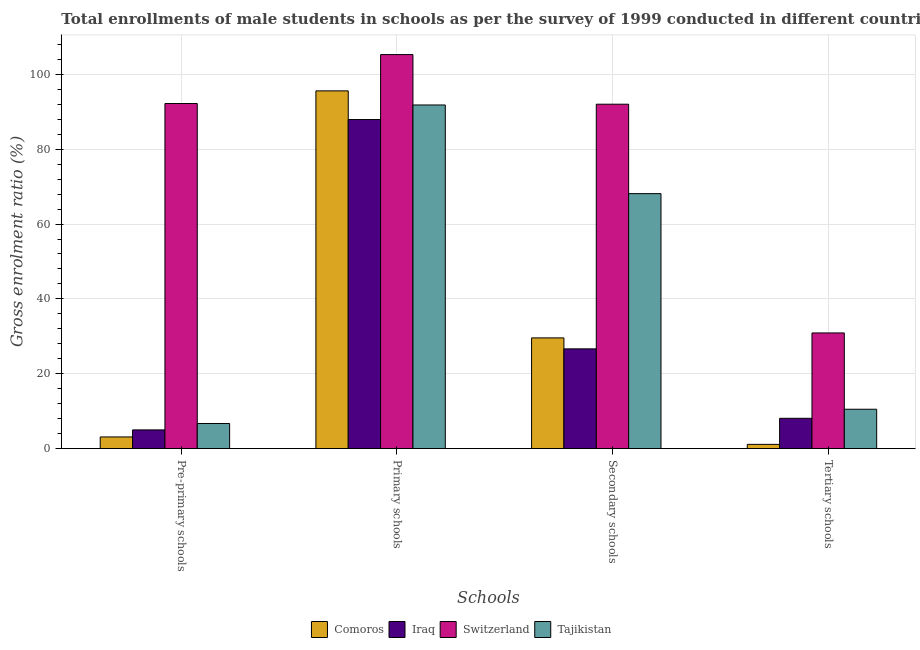How many groups of bars are there?
Your answer should be very brief. 4. Are the number of bars per tick equal to the number of legend labels?
Your response must be concise. Yes. Are the number of bars on each tick of the X-axis equal?
Make the answer very short. Yes. How many bars are there on the 3rd tick from the left?
Provide a short and direct response. 4. What is the label of the 3rd group of bars from the left?
Your answer should be compact. Secondary schools. What is the gross enrolment ratio(male) in tertiary schools in Switzerland?
Give a very brief answer. 30.91. Across all countries, what is the maximum gross enrolment ratio(male) in tertiary schools?
Provide a succinct answer. 30.91. Across all countries, what is the minimum gross enrolment ratio(male) in pre-primary schools?
Provide a succinct answer. 3.13. In which country was the gross enrolment ratio(male) in tertiary schools maximum?
Your answer should be very brief. Switzerland. In which country was the gross enrolment ratio(male) in primary schools minimum?
Offer a terse response. Iraq. What is the total gross enrolment ratio(male) in secondary schools in the graph?
Keep it short and to the point. 216.39. What is the difference between the gross enrolment ratio(male) in primary schools in Comoros and that in Switzerland?
Your response must be concise. -9.69. What is the difference between the gross enrolment ratio(male) in tertiary schools in Comoros and the gross enrolment ratio(male) in primary schools in Iraq?
Ensure brevity in your answer.  -86.76. What is the average gross enrolment ratio(male) in pre-primary schools per country?
Your answer should be compact. 26.77. What is the difference between the gross enrolment ratio(male) in secondary schools and gross enrolment ratio(male) in pre-primary schools in Switzerland?
Your response must be concise. -0.18. What is the ratio of the gross enrolment ratio(male) in primary schools in Iraq to that in Tajikistan?
Your answer should be very brief. 0.96. Is the gross enrolment ratio(male) in tertiary schools in Tajikistan less than that in Comoros?
Provide a short and direct response. No. Is the difference between the gross enrolment ratio(male) in pre-primary schools in Tajikistan and Switzerland greater than the difference between the gross enrolment ratio(male) in secondary schools in Tajikistan and Switzerland?
Make the answer very short. No. What is the difference between the highest and the second highest gross enrolment ratio(male) in tertiary schools?
Ensure brevity in your answer.  20.38. What is the difference between the highest and the lowest gross enrolment ratio(male) in pre-primary schools?
Provide a succinct answer. 89.06. Is it the case that in every country, the sum of the gross enrolment ratio(male) in pre-primary schools and gross enrolment ratio(male) in secondary schools is greater than the sum of gross enrolment ratio(male) in tertiary schools and gross enrolment ratio(male) in primary schools?
Provide a succinct answer. No. What does the 3rd bar from the left in Secondary schools represents?
Offer a very short reply. Switzerland. What does the 1st bar from the right in Secondary schools represents?
Keep it short and to the point. Tajikistan. Is it the case that in every country, the sum of the gross enrolment ratio(male) in pre-primary schools and gross enrolment ratio(male) in primary schools is greater than the gross enrolment ratio(male) in secondary schools?
Your response must be concise. Yes. Are all the bars in the graph horizontal?
Your response must be concise. No. How many legend labels are there?
Your answer should be compact. 4. What is the title of the graph?
Your answer should be compact. Total enrollments of male students in schools as per the survey of 1999 conducted in different countries. What is the label or title of the X-axis?
Your answer should be very brief. Schools. What is the label or title of the Y-axis?
Provide a succinct answer. Gross enrolment ratio (%). What is the Gross enrolment ratio (%) in Comoros in Pre-primary schools?
Offer a terse response. 3.13. What is the Gross enrolment ratio (%) of Iraq in Pre-primary schools?
Provide a short and direct response. 5.02. What is the Gross enrolment ratio (%) of Switzerland in Pre-primary schools?
Provide a short and direct response. 92.19. What is the Gross enrolment ratio (%) in Tajikistan in Pre-primary schools?
Your answer should be very brief. 6.73. What is the Gross enrolment ratio (%) in Comoros in Primary schools?
Your response must be concise. 95.57. What is the Gross enrolment ratio (%) of Iraq in Primary schools?
Give a very brief answer. 87.92. What is the Gross enrolment ratio (%) of Switzerland in Primary schools?
Ensure brevity in your answer.  105.27. What is the Gross enrolment ratio (%) of Tajikistan in Primary schools?
Keep it short and to the point. 91.8. What is the Gross enrolment ratio (%) of Comoros in Secondary schools?
Offer a very short reply. 29.59. What is the Gross enrolment ratio (%) of Iraq in Secondary schools?
Make the answer very short. 26.66. What is the Gross enrolment ratio (%) of Switzerland in Secondary schools?
Make the answer very short. 92.01. What is the Gross enrolment ratio (%) of Tajikistan in Secondary schools?
Keep it short and to the point. 68.13. What is the Gross enrolment ratio (%) in Comoros in Tertiary schools?
Your response must be concise. 1.15. What is the Gross enrolment ratio (%) in Iraq in Tertiary schools?
Give a very brief answer. 8.11. What is the Gross enrolment ratio (%) in Switzerland in Tertiary schools?
Provide a succinct answer. 30.91. What is the Gross enrolment ratio (%) of Tajikistan in Tertiary schools?
Your answer should be very brief. 10.53. Across all Schools, what is the maximum Gross enrolment ratio (%) in Comoros?
Your answer should be compact. 95.57. Across all Schools, what is the maximum Gross enrolment ratio (%) of Iraq?
Offer a very short reply. 87.92. Across all Schools, what is the maximum Gross enrolment ratio (%) of Switzerland?
Provide a short and direct response. 105.27. Across all Schools, what is the maximum Gross enrolment ratio (%) in Tajikistan?
Your answer should be compact. 91.8. Across all Schools, what is the minimum Gross enrolment ratio (%) in Comoros?
Ensure brevity in your answer.  1.15. Across all Schools, what is the minimum Gross enrolment ratio (%) of Iraq?
Offer a terse response. 5.02. Across all Schools, what is the minimum Gross enrolment ratio (%) of Switzerland?
Your response must be concise. 30.91. Across all Schools, what is the minimum Gross enrolment ratio (%) in Tajikistan?
Give a very brief answer. 6.73. What is the total Gross enrolment ratio (%) of Comoros in the graph?
Make the answer very short. 129.45. What is the total Gross enrolment ratio (%) in Iraq in the graph?
Offer a very short reply. 127.71. What is the total Gross enrolment ratio (%) in Switzerland in the graph?
Give a very brief answer. 320.38. What is the total Gross enrolment ratio (%) in Tajikistan in the graph?
Give a very brief answer. 177.19. What is the difference between the Gross enrolment ratio (%) of Comoros in Pre-primary schools and that in Primary schools?
Your answer should be compact. -92.44. What is the difference between the Gross enrolment ratio (%) of Iraq in Pre-primary schools and that in Primary schools?
Make the answer very short. -82.9. What is the difference between the Gross enrolment ratio (%) of Switzerland in Pre-primary schools and that in Primary schools?
Ensure brevity in your answer.  -13.07. What is the difference between the Gross enrolment ratio (%) in Tajikistan in Pre-primary schools and that in Primary schools?
Offer a very short reply. -85.08. What is the difference between the Gross enrolment ratio (%) of Comoros in Pre-primary schools and that in Secondary schools?
Your answer should be very brief. -26.45. What is the difference between the Gross enrolment ratio (%) of Iraq in Pre-primary schools and that in Secondary schools?
Your answer should be compact. -21.65. What is the difference between the Gross enrolment ratio (%) in Switzerland in Pre-primary schools and that in Secondary schools?
Your response must be concise. 0.18. What is the difference between the Gross enrolment ratio (%) in Tajikistan in Pre-primary schools and that in Secondary schools?
Make the answer very short. -61.4. What is the difference between the Gross enrolment ratio (%) in Comoros in Pre-primary schools and that in Tertiary schools?
Your answer should be very brief. 1.98. What is the difference between the Gross enrolment ratio (%) in Iraq in Pre-primary schools and that in Tertiary schools?
Offer a very short reply. -3.1. What is the difference between the Gross enrolment ratio (%) of Switzerland in Pre-primary schools and that in Tertiary schools?
Your answer should be compact. 61.28. What is the difference between the Gross enrolment ratio (%) in Tajikistan in Pre-primary schools and that in Tertiary schools?
Ensure brevity in your answer.  -3.81. What is the difference between the Gross enrolment ratio (%) in Comoros in Primary schools and that in Secondary schools?
Your answer should be very brief. 65.98. What is the difference between the Gross enrolment ratio (%) of Iraq in Primary schools and that in Secondary schools?
Keep it short and to the point. 61.25. What is the difference between the Gross enrolment ratio (%) in Switzerland in Primary schools and that in Secondary schools?
Your answer should be compact. 13.26. What is the difference between the Gross enrolment ratio (%) in Tajikistan in Primary schools and that in Secondary schools?
Keep it short and to the point. 23.68. What is the difference between the Gross enrolment ratio (%) in Comoros in Primary schools and that in Tertiary schools?
Your response must be concise. 94.42. What is the difference between the Gross enrolment ratio (%) of Iraq in Primary schools and that in Tertiary schools?
Provide a succinct answer. 79.8. What is the difference between the Gross enrolment ratio (%) in Switzerland in Primary schools and that in Tertiary schools?
Provide a short and direct response. 74.35. What is the difference between the Gross enrolment ratio (%) in Tajikistan in Primary schools and that in Tertiary schools?
Provide a short and direct response. 81.27. What is the difference between the Gross enrolment ratio (%) of Comoros in Secondary schools and that in Tertiary schools?
Offer a very short reply. 28.44. What is the difference between the Gross enrolment ratio (%) of Iraq in Secondary schools and that in Tertiary schools?
Offer a terse response. 18.55. What is the difference between the Gross enrolment ratio (%) in Switzerland in Secondary schools and that in Tertiary schools?
Provide a succinct answer. 61.1. What is the difference between the Gross enrolment ratio (%) of Tajikistan in Secondary schools and that in Tertiary schools?
Your answer should be compact. 57.59. What is the difference between the Gross enrolment ratio (%) in Comoros in Pre-primary schools and the Gross enrolment ratio (%) in Iraq in Primary schools?
Give a very brief answer. -84.78. What is the difference between the Gross enrolment ratio (%) of Comoros in Pre-primary schools and the Gross enrolment ratio (%) of Switzerland in Primary schools?
Ensure brevity in your answer.  -102.13. What is the difference between the Gross enrolment ratio (%) in Comoros in Pre-primary schools and the Gross enrolment ratio (%) in Tajikistan in Primary schools?
Keep it short and to the point. -88.67. What is the difference between the Gross enrolment ratio (%) of Iraq in Pre-primary schools and the Gross enrolment ratio (%) of Switzerland in Primary schools?
Offer a very short reply. -100.25. What is the difference between the Gross enrolment ratio (%) of Iraq in Pre-primary schools and the Gross enrolment ratio (%) of Tajikistan in Primary schools?
Make the answer very short. -86.79. What is the difference between the Gross enrolment ratio (%) in Switzerland in Pre-primary schools and the Gross enrolment ratio (%) in Tajikistan in Primary schools?
Offer a very short reply. 0.39. What is the difference between the Gross enrolment ratio (%) in Comoros in Pre-primary schools and the Gross enrolment ratio (%) in Iraq in Secondary schools?
Make the answer very short. -23.53. What is the difference between the Gross enrolment ratio (%) of Comoros in Pre-primary schools and the Gross enrolment ratio (%) of Switzerland in Secondary schools?
Ensure brevity in your answer.  -88.88. What is the difference between the Gross enrolment ratio (%) of Comoros in Pre-primary schools and the Gross enrolment ratio (%) of Tajikistan in Secondary schools?
Offer a very short reply. -64.99. What is the difference between the Gross enrolment ratio (%) in Iraq in Pre-primary schools and the Gross enrolment ratio (%) in Switzerland in Secondary schools?
Your answer should be compact. -86.99. What is the difference between the Gross enrolment ratio (%) of Iraq in Pre-primary schools and the Gross enrolment ratio (%) of Tajikistan in Secondary schools?
Offer a very short reply. -63.11. What is the difference between the Gross enrolment ratio (%) in Switzerland in Pre-primary schools and the Gross enrolment ratio (%) in Tajikistan in Secondary schools?
Your answer should be very brief. 24.07. What is the difference between the Gross enrolment ratio (%) of Comoros in Pre-primary schools and the Gross enrolment ratio (%) of Iraq in Tertiary schools?
Offer a terse response. -4.98. What is the difference between the Gross enrolment ratio (%) in Comoros in Pre-primary schools and the Gross enrolment ratio (%) in Switzerland in Tertiary schools?
Your response must be concise. -27.78. What is the difference between the Gross enrolment ratio (%) in Comoros in Pre-primary schools and the Gross enrolment ratio (%) in Tajikistan in Tertiary schools?
Offer a very short reply. -7.4. What is the difference between the Gross enrolment ratio (%) in Iraq in Pre-primary schools and the Gross enrolment ratio (%) in Switzerland in Tertiary schools?
Make the answer very short. -25.9. What is the difference between the Gross enrolment ratio (%) of Iraq in Pre-primary schools and the Gross enrolment ratio (%) of Tajikistan in Tertiary schools?
Your answer should be very brief. -5.52. What is the difference between the Gross enrolment ratio (%) of Switzerland in Pre-primary schools and the Gross enrolment ratio (%) of Tajikistan in Tertiary schools?
Your answer should be very brief. 81.66. What is the difference between the Gross enrolment ratio (%) of Comoros in Primary schools and the Gross enrolment ratio (%) of Iraq in Secondary schools?
Ensure brevity in your answer.  68.91. What is the difference between the Gross enrolment ratio (%) of Comoros in Primary schools and the Gross enrolment ratio (%) of Switzerland in Secondary schools?
Keep it short and to the point. 3.56. What is the difference between the Gross enrolment ratio (%) in Comoros in Primary schools and the Gross enrolment ratio (%) in Tajikistan in Secondary schools?
Make the answer very short. 27.45. What is the difference between the Gross enrolment ratio (%) in Iraq in Primary schools and the Gross enrolment ratio (%) in Switzerland in Secondary schools?
Offer a very short reply. -4.09. What is the difference between the Gross enrolment ratio (%) in Iraq in Primary schools and the Gross enrolment ratio (%) in Tajikistan in Secondary schools?
Your answer should be compact. 19.79. What is the difference between the Gross enrolment ratio (%) of Switzerland in Primary schools and the Gross enrolment ratio (%) of Tajikistan in Secondary schools?
Give a very brief answer. 37.14. What is the difference between the Gross enrolment ratio (%) in Comoros in Primary schools and the Gross enrolment ratio (%) in Iraq in Tertiary schools?
Your answer should be very brief. 87.46. What is the difference between the Gross enrolment ratio (%) in Comoros in Primary schools and the Gross enrolment ratio (%) in Switzerland in Tertiary schools?
Give a very brief answer. 64.66. What is the difference between the Gross enrolment ratio (%) in Comoros in Primary schools and the Gross enrolment ratio (%) in Tajikistan in Tertiary schools?
Keep it short and to the point. 85.04. What is the difference between the Gross enrolment ratio (%) in Iraq in Primary schools and the Gross enrolment ratio (%) in Switzerland in Tertiary schools?
Ensure brevity in your answer.  57. What is the difference between the Gross enrolment ratio (%) in Iraq in Primary schools and the Gross enrolment ratio (%) in Tajikistan in Tertiary schools?
Offer a terse response. 77.38. What is the difference between the Gross enrolment ratio (%) of Switzerland in Primary schools and the Gross enrolment ratio (%) of Tajikistan in Tertiary schools?
Give a very brief answer. 94.73. What is the difference between the Gross enrolment ratio (%) of Comoros in Secondary schools and the Gross enrolment ratio (%) of Iraq in Tertiary schools?
Your answer should be compact. 21.48. What is the difference between the Gross enrolment ratio (%) of Comoros in Secondary schools and the Gross enrolment ratio (%) of Switzerland in Tertiary schools?
Your answer should be very brief. -1.33. What is the difference between the Gross enrolment ratio (%) in Comoros in Secondary schools and the Gross enrolment ratio (%) in Tajikistan in Tertiary schools?
Ensure brevity in your answer.  19.05. What is the difference between the Gross enrolment ratio (%) in Iraq in Secondary schools and the Gross enrolment ratio (%) in Switzerland in Tertiary schools?
Make the answer very short. -4.25. What is the difference between the Gross enrolment ratio (%) of Iraq in Secondary schools and the Gross enrolment ratio (%) of Tajikistan in Tertiary schools?
Your response must be concise. 16.13. What is the difference between the Gross enrolment ratio (%) of Switzerland in Secondary schools and the Gross enrolment ratio (%) of Tajikistan in Tertiary schools?
Your answer should be very brief. 81.47. What is the average Gross enrolment ratio (%) in Comoros per Schools?
Give a very brief answer. 32.36. What is the average Gross enrolment ratio (%) in Iraq per Schools?
Give a very brief answer. 31.93. What is the average Gross enrolment ratio (%) of Switzerland per Schools?
Provide a succinct answer. 80.1. What is the average Gross enrolment ratio (%) of Tajikistan per Schools?
Keep it short and to the point. 44.3. What is the difference between the Gross enrolment ratio (%) of Comoros and Gross enrolment ratio (%) of Iraq in Pre-primary schools?
Ensure brevity in your answer.  -1.88. What is the difference between the Gross enrolment ratio (%) of Comoros and Gross enrolment ratio (%) of Switzerland in Pre-primary schools?
Offer a terse response. -89.06. What is the difference between the Gross enrolment ratio (%) of Comoros and Gross enrolment ratio (%) of Tajikistan in Pre-primary schools?
Keep it short and to the point. -3.59. What is the difference between the Gross enrolment ratio (%) of Iraq and Gross enrolment ratio (%) of Switzerland in Pre-primary schools?
Make the answer very short. -87.18. What is the difference between the Gross enrolment ratio (%) of Iraq and Gross enrolment ratio (%) of Tajikistan in Pre-primary schools?
Give a very brief answer. -1.71. What is the difference between the Gross enrolment ratio (%) in Switzerland and Gross enrolment ratio (%) in Tajikistan in Pre-primary schools?
Offer a very short reply. 85.47. What is the difference between the Gross enrolment ratio (%) of Comoros and Gross enrolment ratio (%) of Iraq in Primary schools?
Offer a very short reply. 7.66. What is the difference between the Gross enrolment ratio (%) of Comoros and Gross enrolment ratio (%) of Switzerland in Primary schools?
Keep it short and to the point. -9.69. What is the difference between the Gross enrolment ratio (%) in Comoros and Gross enrolment ratio (%) in Tajikistan in Primary schools?
Provide a succinct answer. 3.77. What is the difference between the Gross enrolment ratio (%) of Iraq and Gross enrolment ratio (%) of Switzerland in Primary schools?
Your response must be concise. -17.35. What is the difference between the Gross enrolment ratio (%) of Iraq and Gross enrolment ratio (%) of Tajikistan in Primary schools?
Provide a short and direct response. -3.89. What is the difference between the Gross enrolment ratio (%) in Switzerland and Gross enrolment ratio (%) in Tajikistan in Primary schools?
Keep it short and to the point. 13.46. What is the difference between the Gross enrolment ratio (%) in Comoros and Gross enrolment ratio (%) in Iraq in Secondary schools?
Make the answer very short. 2.93. What is the difference between the Gross enrolment ratio (%) in Comoros and Gross enrolment ratio (%) in Switzerland in Secondary schools?
Your answer should be very brief. -62.42. What is the difference between the Gross enrolment ratio (%) in Comoros and Gross enrolment ratio (%) in Tajikistan in Secondary schools?
Offer a terse response. -38.54. What is the difference between the Gross enrolment ratio (%) in Iraq and Gross enrolment ratio (%) in Switzerland in Secondary schools?
Offer a very short reply. -65.35. What is the difference between the Gross enrolment ratio (%) of Iraq and Gross enrolment ratio (%) of Tajikistan in Secondary schools?
Your answer should be compact. -41.46. What is the difference between the Gross enrolment ratio (%) of Switzerland and Gross enrolment ratio (%) of Tajikistan in Secondary schools?
Provide a short and direct response. 23.88. What is the difference between the Gross enrolment ratio (%) in Comoros and Gross enrolment ratio (%) in Iraq in Tertiary schools?
Your response must be concise. -6.96. What is the difference between the Gross enrolment ratio (%) of Comoros and Gross enrolment ratio (%) of Switzerland in Tertiary schools?
Offer a very short reply. -29.76. What is the difference between the Gross enrolment ratio (%) of Comoros and Gross enrolment ratio (%) of Tajikistan in Tertiary schools?
Your answer should be very brief. -9.38. What is the difference between the Gross enrolment ratio (%) in Iraq and Gross enrolment ratio (%) in Switzerland in Tertiary schools?
Make the answer very short. -22.8. What is the difference between the Gross enrolment ratio (%) of Iraq and Gross enrolment ratio (%) of Tajikistan in Tertiary schools?
Give a very brief answer. -2.42. What is the difference between the Gross enrolment ratio (%) in Switzerland and Gross enrolment ratio (%) in Tajikistan in Tertiary schools?
Give a very brief answer. 20.38. What is the ratio of the Gross enrolment ratio (%) of Comoros in Pre-primary schools to that in Primary schools?
Offer a very short reply. 0.03. What is the ratio of the Gross enrolment ratio (%) of Iraq in Pre-primary schools to that in Primary schools?
Offer a very short reply. 0.06. What is the ratio of the Gross enrolment ratio (%) of Switzerland in Pre-primary schools to that in Primary schools?
Your answer should be compact. 0.88. What is the ratio of the Gross enrolment ratio (%) in Tajikistan in Pre-primary schools to that in Primary schools?
Provide a succinct answer. 0.07. What is the ratio of the Gross enrolment ratio (%) of Comoros in Pre-primary schools to that in Secondary schools?
Offer a very short reply. 0.11. What is the ratio of the Gross enrolment ratio (%) of Iraq in Pre-primary schools to that in Secondary schools?
Give a very brief answer. 0.19. What is the ratio of the Gross enrolment ratio (%) in Tajikistan in Pre-primary schools to that in Secondary schools?
Provide a succinct answer. 0.1. What is the ratio of the Gross enrolment ratio (%) in Comoros in Pre-primary schools to that in Tertiary schools?
Give a very brief answer. 2.72. What is the ratio of the Gross enrolment ratio (%) in Iraq in Pre-primary schools to that in Tertiary schools?
Keep it short and to the point. 0.62. What is the ratio of the Gross enrolment ratio (%) in Switzerland in Pre-primary schools to that in Tertiary schools?
Give a very brief answer. 2.98. What is the ratio of the Gross enrolment ratio (%) of Tajikistan in Pre-primary schools to that in Tertiary schools?
Provide a short and direct response. 0.64. What is the ratio of the Gross enrolment ratio (%) in Comoros in Primary schools to that in Secondary schools?
Ensure brevity in your answer.  3.23. What is the ratio of the Gross enrolment ratio (%) in Iraq in Primary schools to that in Secondary schools?
Your answer should be very brief. 3.3. What is the ratio of the Gross enrolment ratio (%) in Switzerland in Primary schools to that in Secondary schools?
Your answer should be very brief. 1.14. What is the ratio of the Gross enrolment ratio (%) of Tajikistan in Primary schools to that in Secondary schools?
Your response must be concise. 1.35. What is the ratio of the Gross enrolment ratio (%) of Comoros in Primary schools to that in Tertiary schools?
Give a very brief answer. 82.98. What is the ratio of the Gross enrolment ratio (%) in Iraq in Primary schools to that in Tertiary schools?
Offer a very short reply. 10.84. What is the ratio of the Gross enrolment ratio (%) in Switzerland in Primary schools to that in Tertiary schools?
Your answer should be compact. 3.41. What is the ratio of the Gross enrolment ratio (%) of Tajikistan in Primary schools to that in Tertiary schools?
Your answer should be compact. 8.71. What is the ratio of the Gross enrolment ratio (%) in Comoros in Secondary schools to that in Tertiary schools?
Keep it short and to the point. 25.69. What is the ratio of the Gross enrolment ratio (%) of Iraq in Secondary schools to that in Tertiary schools?
Give a very brief answer. 3.29. What is the ratio of the Gross enrolment ratio (%) of Switzerland in Secondary schools to that in Tertiary schools?
Give a very brief answer. 2.98. What is the ratio of the Gross enrolment ratio (%) of Tajikistan in Secondary schools to that in Tertiary schools?
Offer a very short reply. 6.47. What is the difference between the highest and the second highest Gross enrolment ratio (%) in Comoros?
Offer a terse response. 65.98. What is the difference between the highest and the second highest Gross enrolment ratio (%) of Iraq?
Keep it short and to the point. 61.25. What is the difference between the highest and the second highest Gross enrolment ratio (%) in Switzerland?
Your response must be concise. 13.07. What is the difference between the highest and the second highest Gross enrolment ratio (%) of Tajikistan?
Offer a terse response. 23.68. What is the difference between the highest and the lowest Gross enrolment ratio (%) in Comoros?
Your answer should be very brief. 94.42. What is the difference between the highest and the lowest Gross enrolment ratio (%) in Iraq?
Provide a short and direct response. 82.9. What is the difference between the highest and the lowest Gross enrolment ratio (%) of Switzerland?
Your answer should be compact. 74.35. What is the difference between the highest and the lowest Gross enrolment ratio (%) of Tajikistan?
Provide a short and direct response. 85.08. 